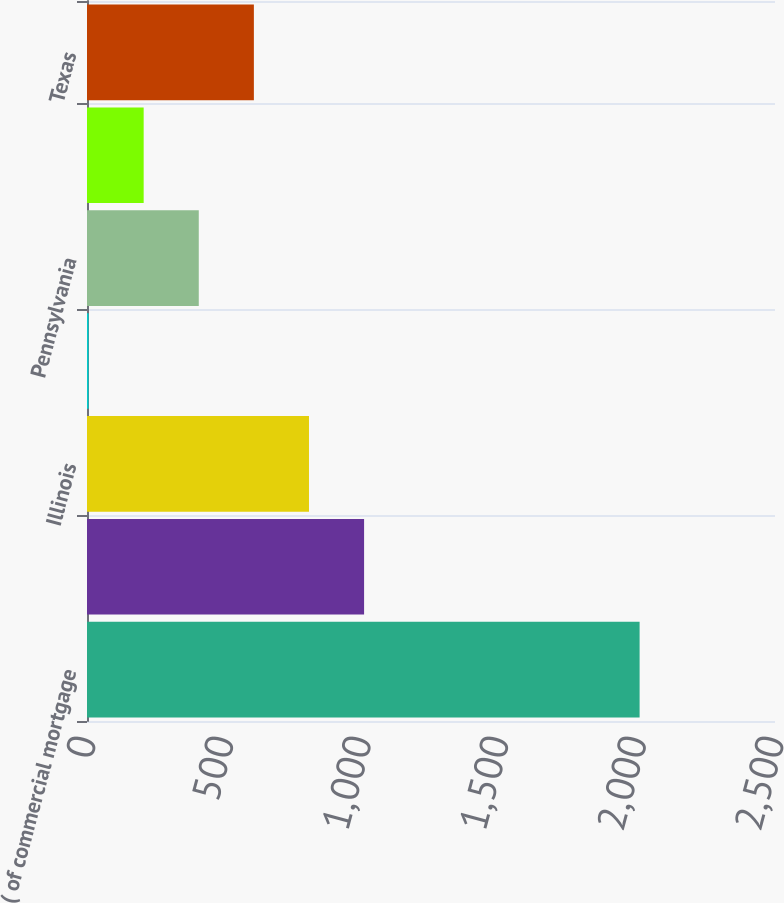Convert chart to OTSL. <chart><loc_0><loc_0><loc_500><loc_500><bar_chart><fcel>( of commercial mortgage<fcel>California<fcel>Illinois<fcel>New York<fcel>Pennsylvania<fcel>New Jersey<fcel>Texas<nl><fcel>2008<fcel>1006.85<fcel>806.62<fcel>5.7<fcel>406.16<fcel>205.93<fcel>606.39<nl></chart> 